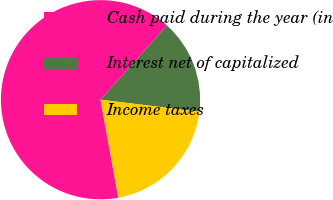Convert chart. <chart><loc_0><loc_0><loc_500><loc_500><pie_chart><fcel>Cash paid during the year (in<fcel>Interest net of capitalized<fcel>Income taxes<nl><fcel>64.48%<fcel>15.3%<fcel>20.22%<nl></chart> 